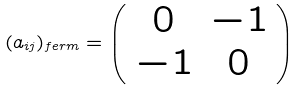Convert formula to latex. <formula><loc_0><loc_0><loc_500><loc_500>( a _ { i j } ) _ { f e r m } = \left ( \begin{array} { c c } 0 & - 1 \\ - 1 & 0 \end{array} \right )</formula> 